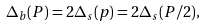Convert formula to latex. <formula><loc_0><loc_0><loc_500><loc_500>\Delta _ { b } ( P ) = 2 \Delta _ { s } ( p ) = 2 \Delta _ { s } ( P / 2 ) ,</formula> 